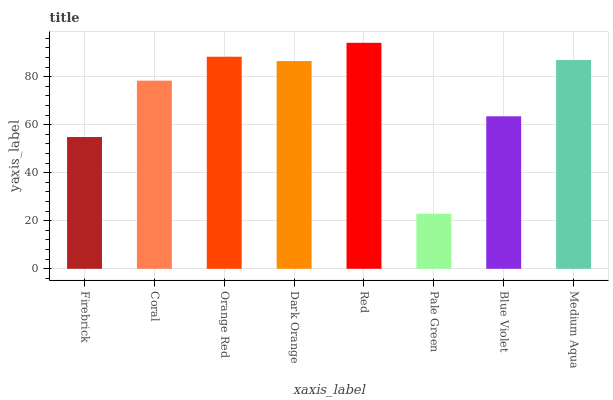Is Pale Green the minimum?
Answer yes or no. Yes. Is Red the maximum?
Answer yes or no. Yes. Is Coral the minimum?
Answer yes or no. No. Is Coral the maximum?
Answer yes or no. No. Is Coral greater than Firebrick?
Answer yes or no. Yes. Is Firebrick less than Coral?
Answer yes or no. Yes. Is Firebrick greater than Coral?
Answer yes or no. No. Is Coral less than Firebrick?
Answer yes or no. No. Is Dark Orange the high median?
Answer yes or no. Yes. Is Coral the low median?
Answer yes or no. Yes. Is Red the high median?
Answer yes or no. No. Is Firebrick the low median?
Answer yes or no. No. 